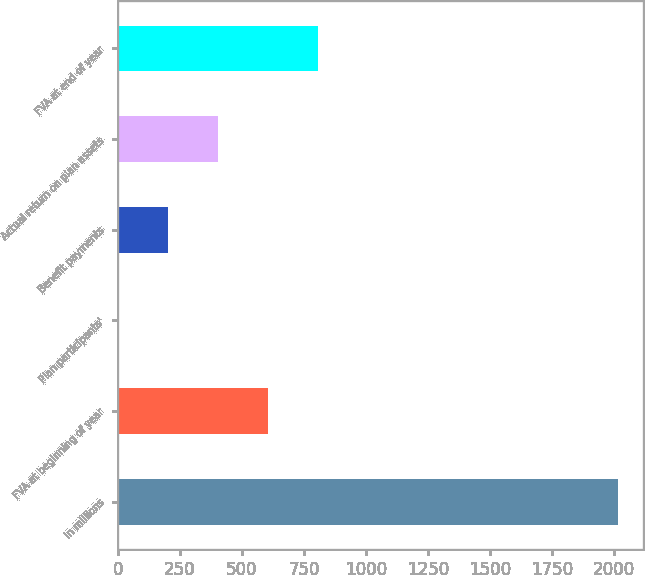Convert chart. <chart><loc_0><loc_0><loc_500><loc_500><bar_chart><fcel>in millions<fcel>FVA at beginning of year<fcel>Plan participants'<fcel>Benefit payments<fcel>Actual return on plan assets<fcel>FVA at end of year<nl><fcel>2017<fcel>605.8<fcel>1<fcel>202.6<fcel>404.2<fcel>807.4<nl></chart> 